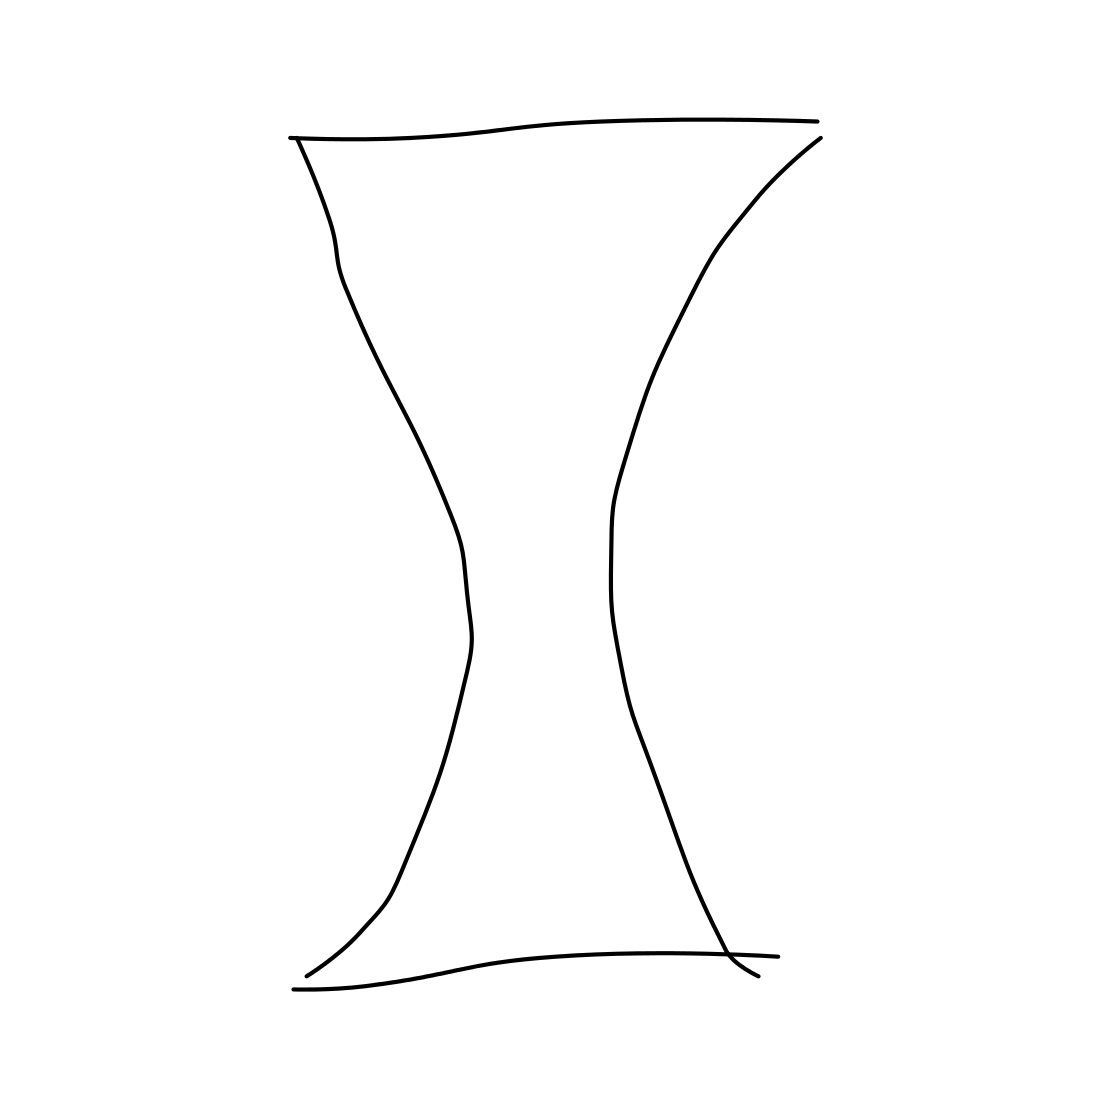Is this an apple in the image? No 